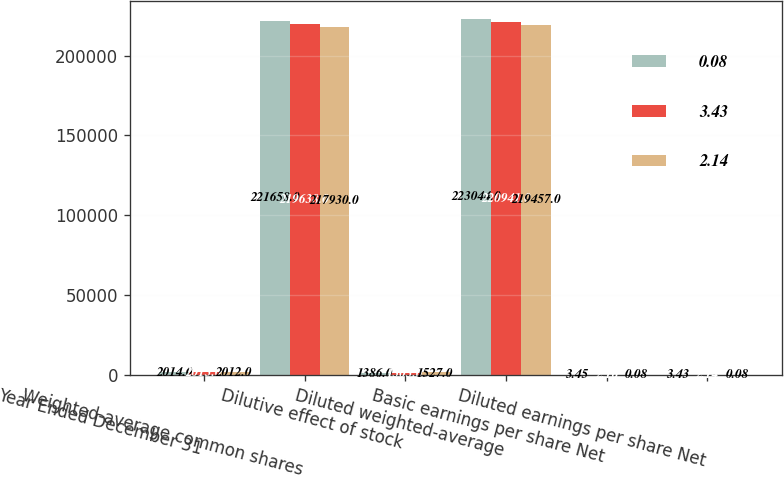Convert chart to OTSL. <chart><loc_0><loc_0><loc_500><loc_500><stacked_bar_chart><ecel><fcel>Year Ended December 31<fcel>Weighted-average common shares<fcel>Dilutive effect of stock<fcel>Diluted weighted-average<fcel>Basic earnings per share Net<fcel>Diluted earnings per share Net<nl><fcel>0.08<fcel>2014<fcel>221658<fcel>1386<fcel>223044<fcel>3.45<fcel>3.43<nl><fcel>3.43<fcel>2013<fcel>219638<fcel>1303<fcel>220941<fcel>2.16<fcel>2.14<nl><fcel>2.14<fcel>2012<fcel>217930<fcel>1527<fcel>219457<fcel>0.08<fcel>0.08<nl></chart> 